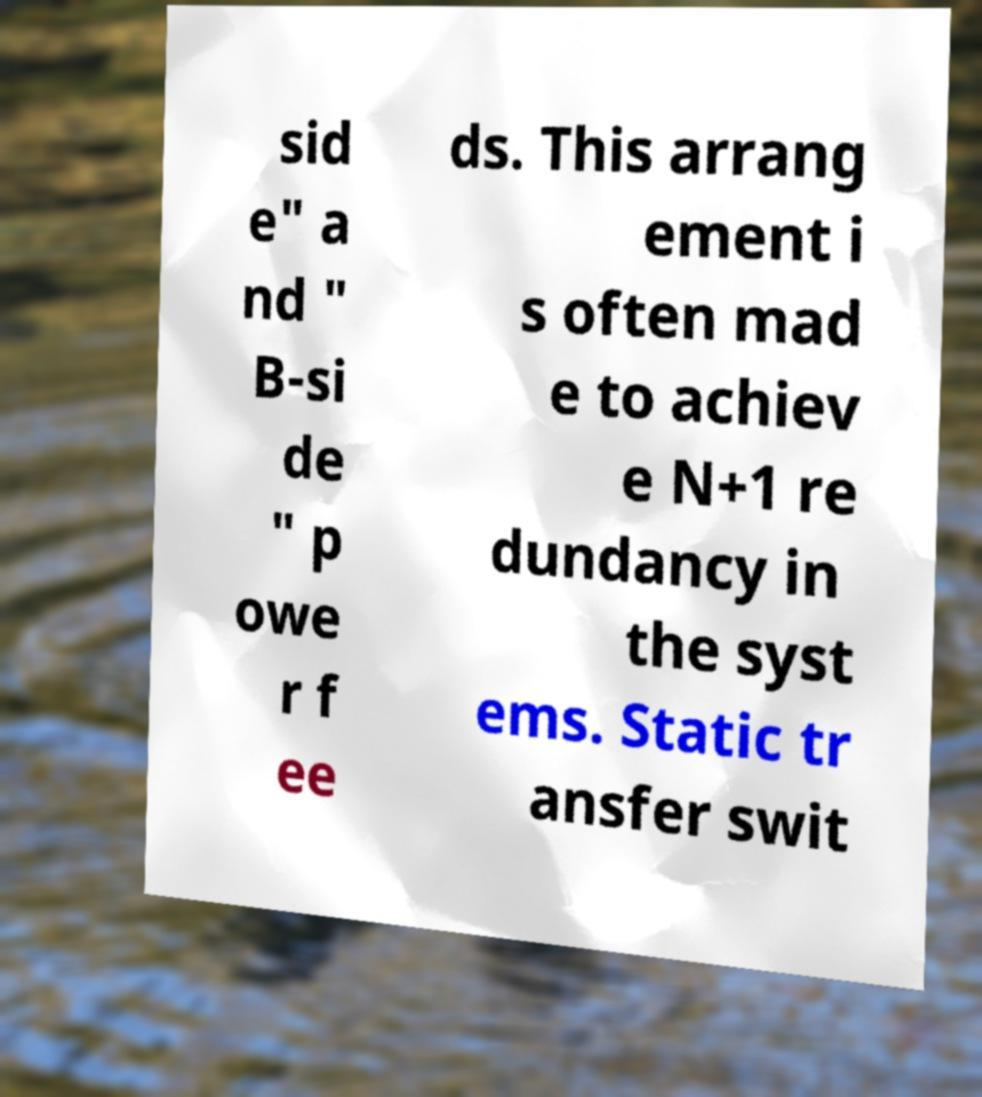For documentation purposes, I need the text within this image transcribed. Could you provide that? sid e" a nd " B-si de " p owe r f ee ds. This arrang ement i s often mad e to achiev e N+1 re dundancy in the syst ems. Static tr ansfer swit 